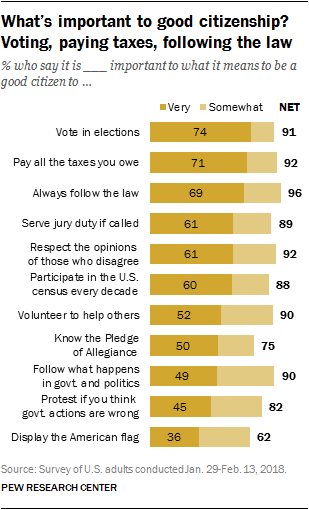Highlight a few significant elements in this photo. The result of adding the first value of "very" to the fourth value of "somewhat" is 163.. The smallest value in the graph is 36. 